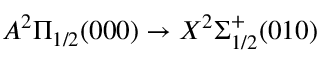<formula> <loc_0><loc_0><loc_500><loc_500>A ^ { 2 } \Pi _ { 1 / 2 } ( 0 0 0 ) \rightarrow X ^ { 2 } \Sigma _ { 1 / 2 } ^ { + } ( 0 1 0 )</formula> 